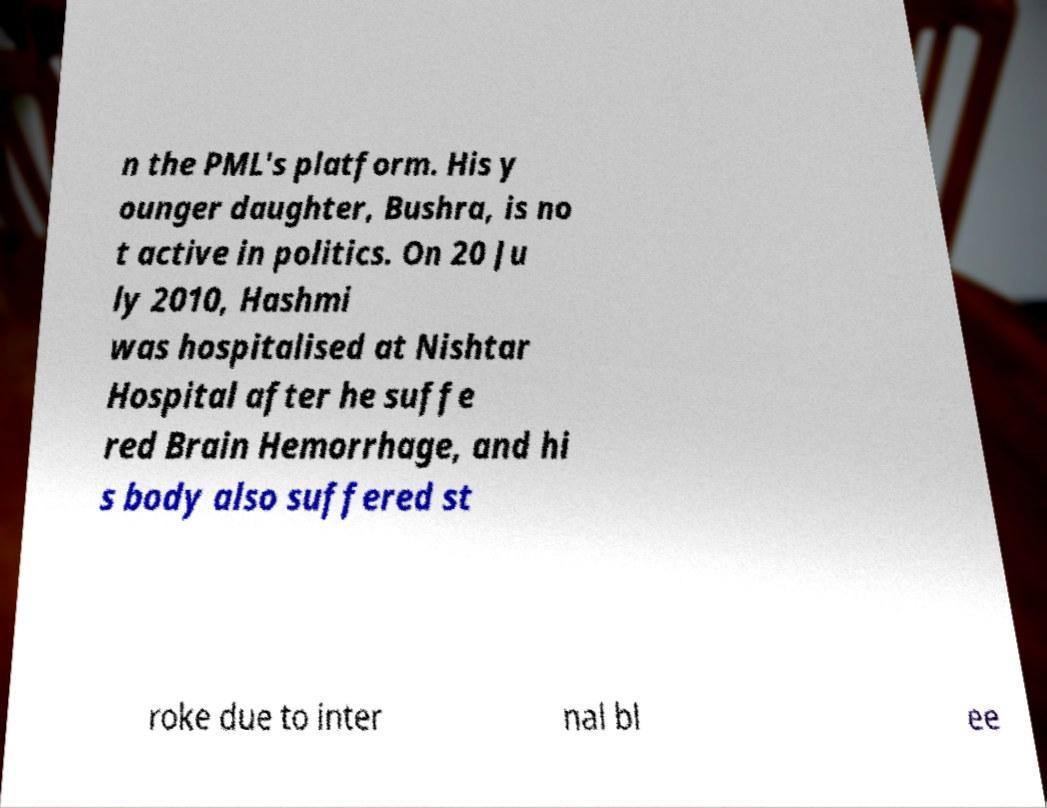Can you accurately transcribe the text from the provided image for me? n the PML's platform. His y ounger daughter, Bushra, is no t active in politics. On 20 Ju ly 2010, Hashmi was hospitalised at Nishtar Hospital after he suffe red Brain Hemorrhage, and hi s body also suffered st roke due to inter nal bl ee 